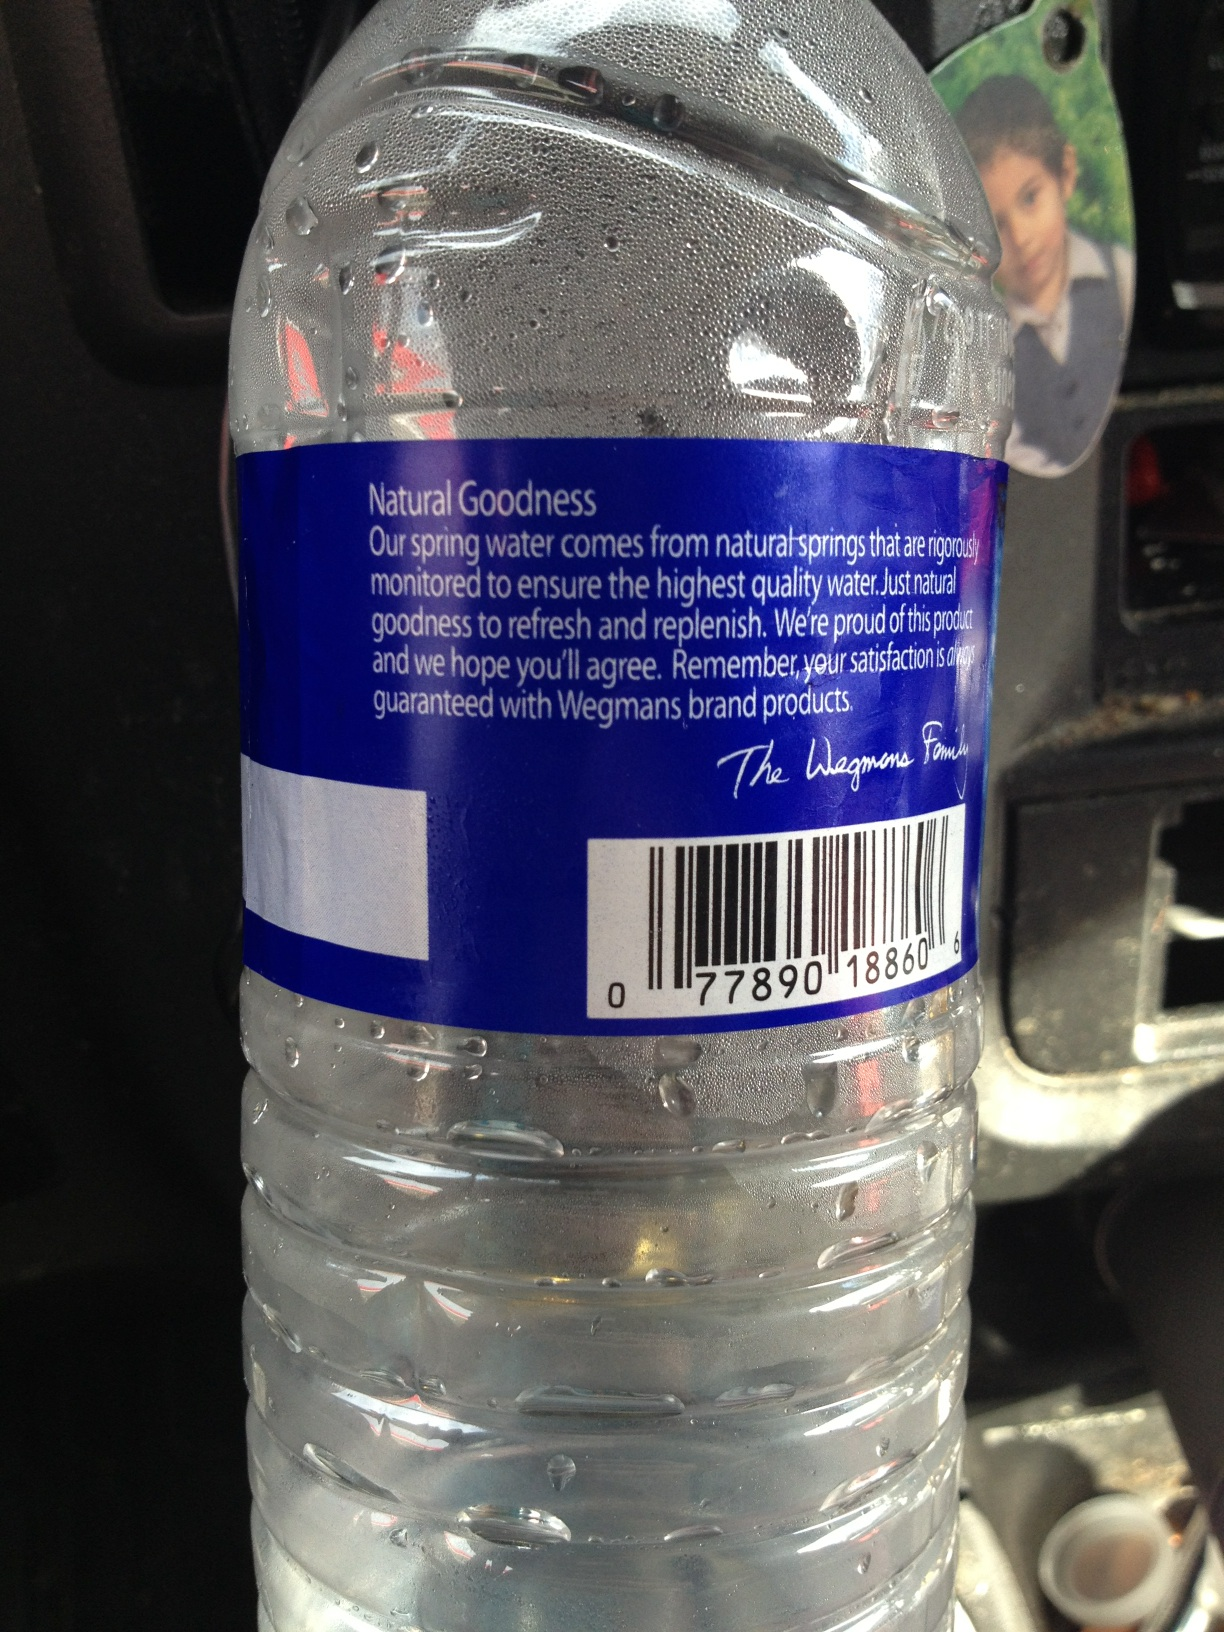Imagine if this water bottle could talk. What would it say about its journey from the spring to the shelf? Hello! I’m a bottle of Wegmans Natural Spring Water. My journey began in a pristine, natural spring, where the water was carefully collected to preserve its purity. I went through various quality control processes, ensuring that I remained pure and refreshing. Then, I was bottled up and transported to a store near you, ready to quench your thirst with natural goodness. 